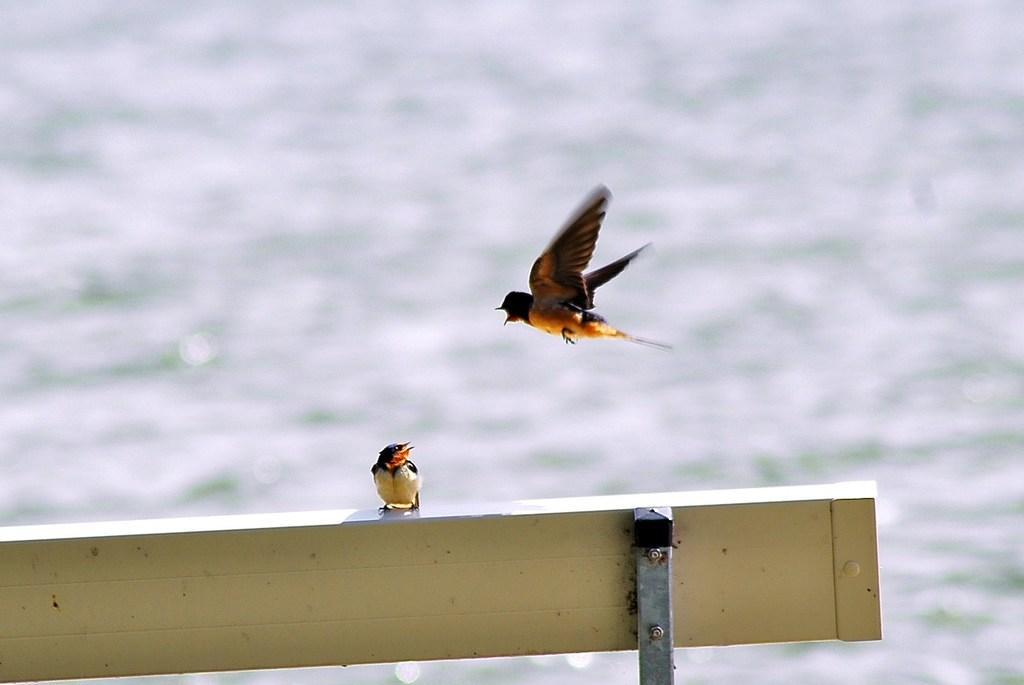In one or two sentences, can you explain what this image depicts? In this picture we can see a bird on the bench, and we can find another bird in the air, in the background we can see water. 